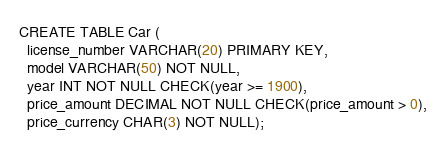Convert code to text. <code><loc_0><loc_0><loc_500><loc_500><_SQL_>CREATE TABLE Car (
  license_number VARCHAR(20) PRIMARY KEY,
  model VARCHAR(50) NOT NULL,
  year INT NOT NULL CHECK(year >= 1900),
  price_amount DECIMAL NOT NULL CHECK(price_amount > 0),
  price_currency CHAR(3) NOT NULL);
</code> 